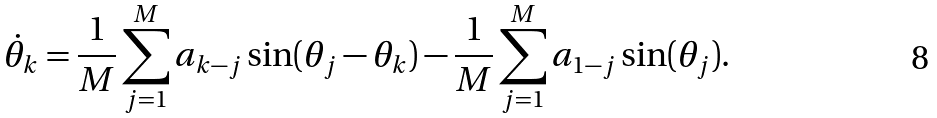Convert formula to latex. <formula><loc_0><loc_0><loc_500><loc_500>\dot { \theta } _ { k } = \frac { 1 } { M } \sum _ { j = 1 } ^ { M } a _ { k - j } \sin ( \theta _ { j } - \theta _ { k } ) - \frac { 1 } { M } \sum _ { j = 1 } ^ { M } a _ { 1 - j } \sin ( \theta _ { j } ) .</formula> 